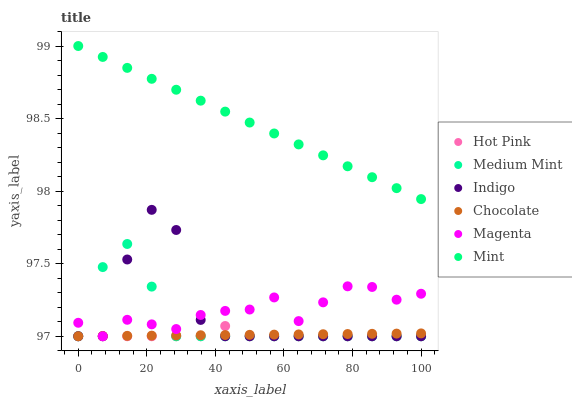Does Hot Pink have the minimum area under the curve?
Answer yes or no. Yes. Does Mint have the maximum area under the curve?
Answer yes or no. Yes. Does Indigo have the minimum area under the curve?
Answer yes or no. No. Does Indigo have the maximum area under the curve?
Answer yes or no. No. Is Chocolate the smoothest?
Answer yes or no. Yes. Is Indigo the roughest?
Answer yes or no. Yes. Is Hot Pink the smoothest?
Answer yes or no. No. Is Hot Pink the roughest?
Answer yes or no. No. Does Medium Mint have the lowest value?
Answer yes or no. Yes. Does Mint have the lowest value?
Answer yes or no. No. Does Mint have the highest value?
Answer yes or no. Yes. Does Indigo have the highest value?
Answer yes or no. No. Is Medium Mint less than Mint?
Answer yes or no. Yes. Is Mint greater than Medium Mint?
Answer yes or no. Yes. Does Medium Mint intersect Indigo?
Answer yes or no. Yes. Is Medium Mint less than Indigo?
Answer yes or no. No. Is Medium Mint greater than Indigo?
Answer yes or no. No. Does Medium Mint intersect Mint?
Answer yes or no. No. 